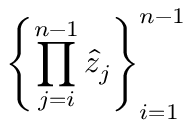Convert formula to latex. <formula><loc_0><loc_0><loc_500><loc_500>\left \{ \prod _ { j = i } ^ { n - 1 } \hat { z } _ { j } \right \} _ { i = 1 } ^ { n - 1 }</formula> 